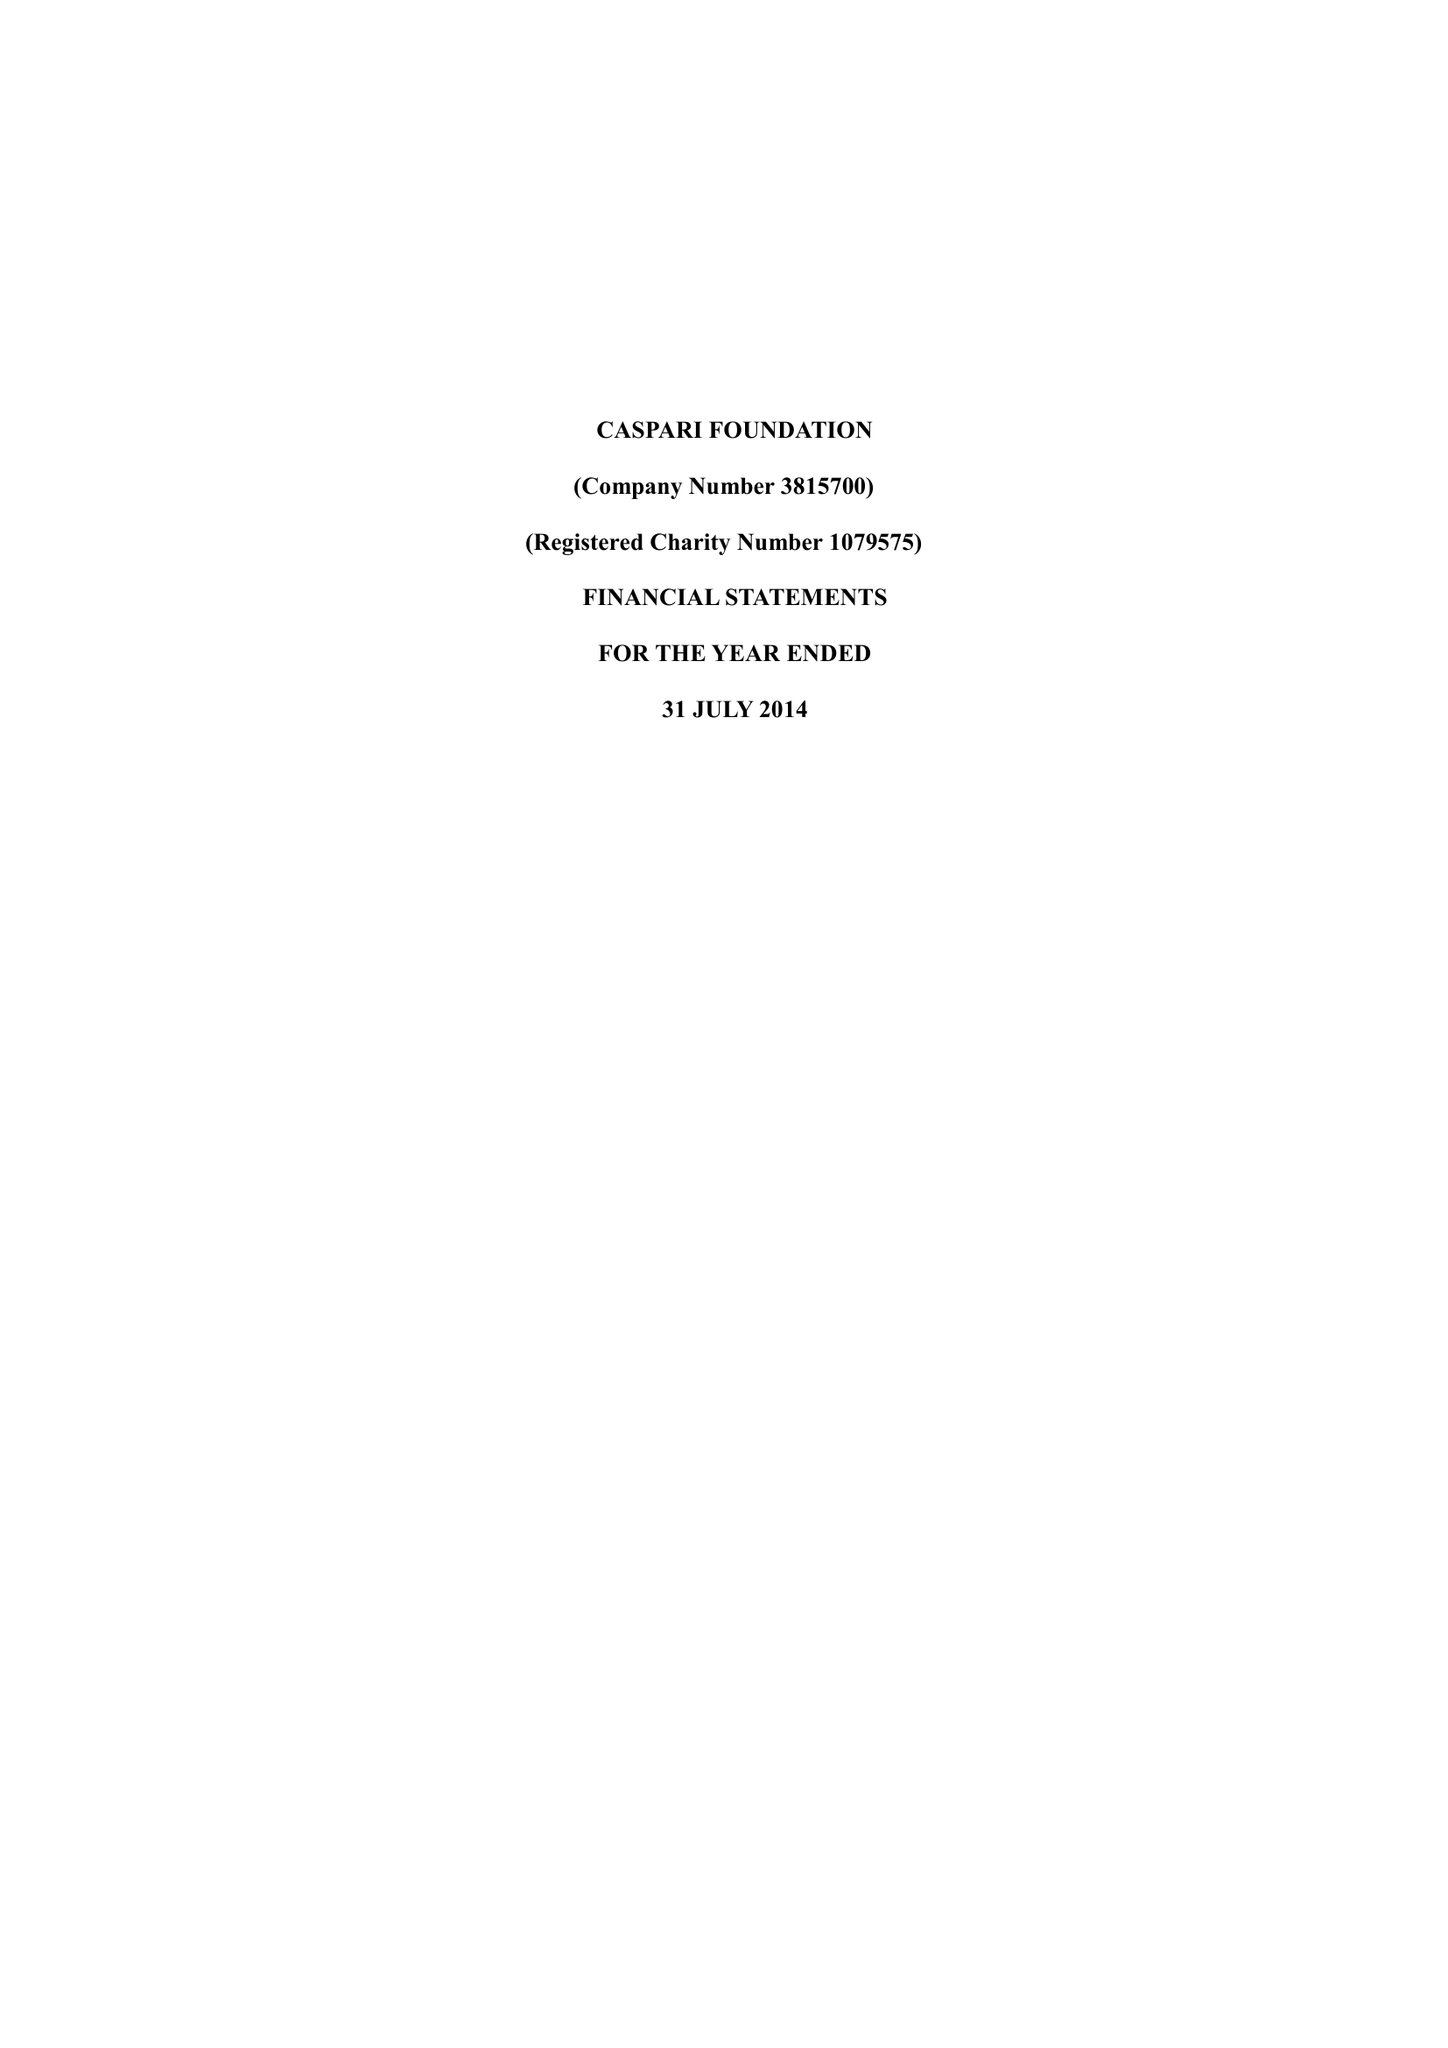What is the value for the charity_name?
Answer the question using a single word or phrase. Caspari Foundation 